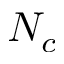<formula> <loc_0><loc_0><loc_500><loc_500>N _ { c }</formula> 